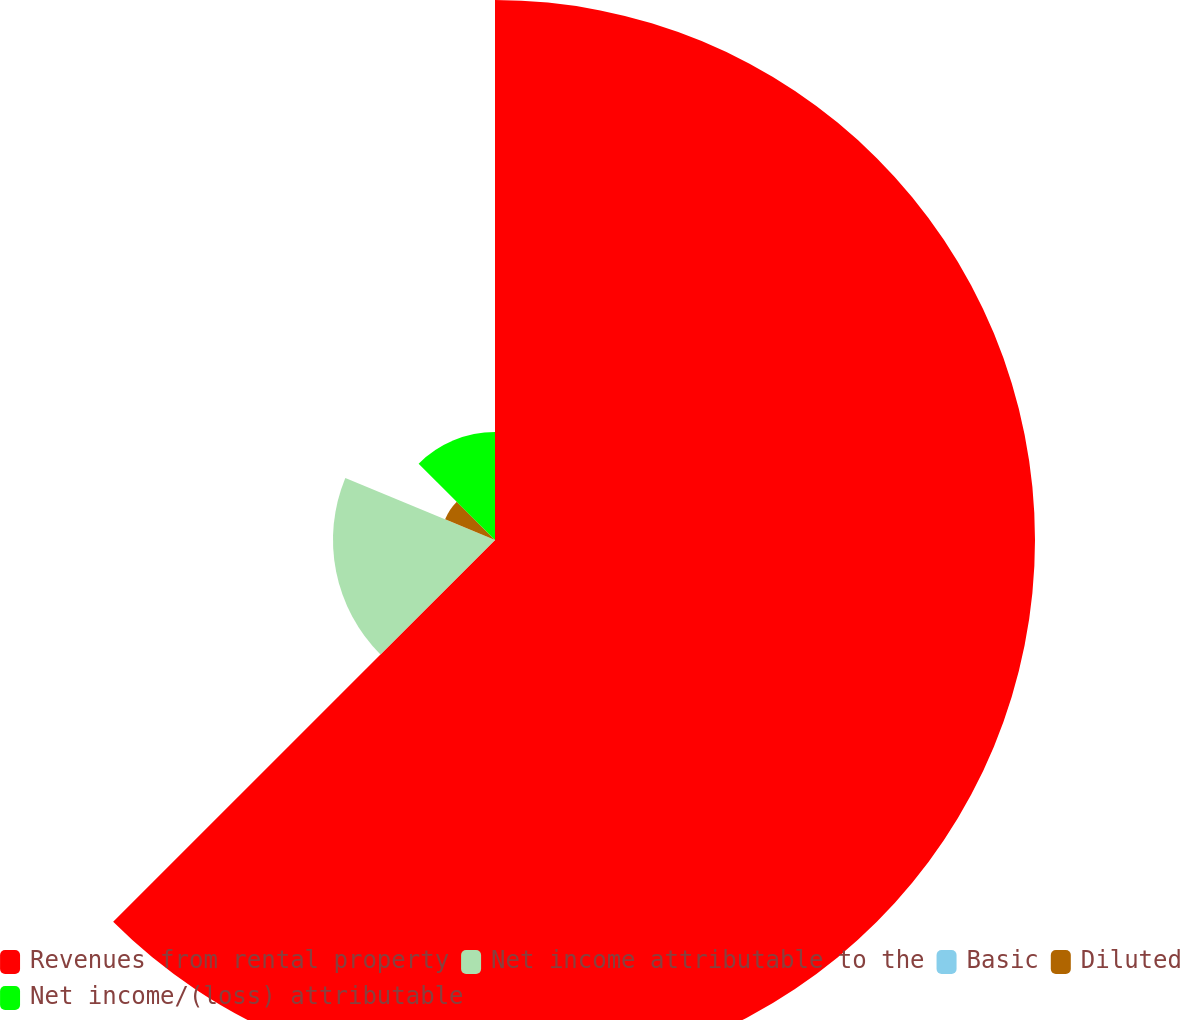Convert chart to OTSL. <chart><loc_0><loc_0><loc_500><loc_500><pie_chart><fcel>Revenues from rental property<fcel>Net income attributable to the<fcel>Basic<fcel>Diluted<fcel>Net income/(loss) attributable<nl><fcel>62.5%<fcel>18.75%<fcel>0.0%<fcel>6.25%<fcel>12.5%<nl></chart> 